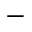<formula> <loc_0><loc_0><loc_500><loc_500>-</formula> 